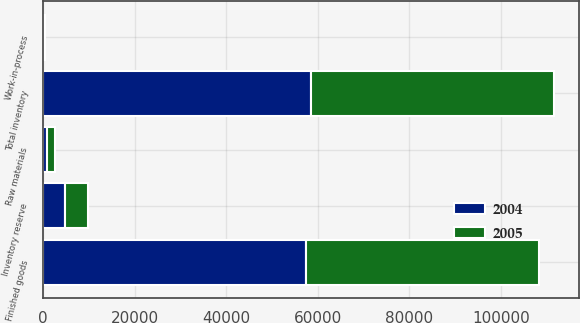<chart> <loc_0><loc_0><loc_500><loc_500><stacked_bar_chart><ecel><fcel>Finished goods<fcel>Raw materials<fcel>Work-in-process<fcel>Total inventory<fcel>Inventory reserve<nl><fcel>2004<fcel>57518<fcel>881<fcel>95<fcel>58494<fcel>4887<nl><fcel>2005<fcel>50802<fcel>1824<fcel>399<fcel>53025<fcel>4970<nl></chart> 